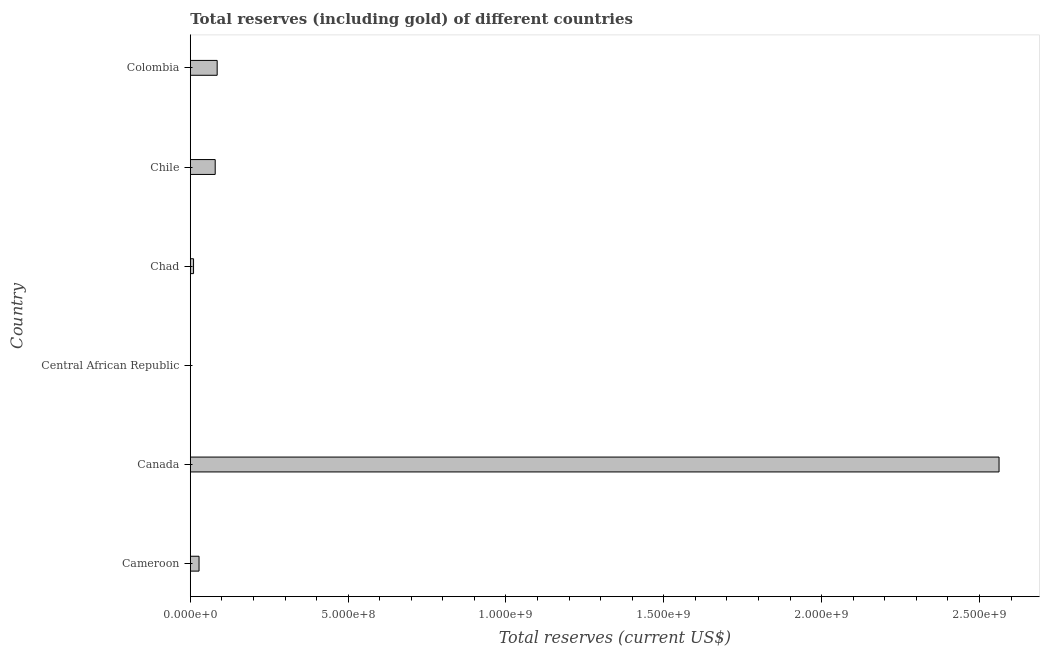Does the graph contain any zero values?
Your response must be concise. No. What is the title of the graph?
Your answer should be very brief. Total reserves (including gold) of different countries. What is the label or title of the X-axis?
Your answer should be very brief. Total reserves (current US$). What is the total reserves (including gold) in Colombia?
Your response must be concise. 8.51e+07. Across all countries, what is the maximum total reserves (including gold)?
Ensure brevity in your answer.  2.56e+09. In which country was the total reserves (including gold) minimum?
Your answer should be very brief. Central African Republic. What is the sum of the total reserves (including gold)?
Your answer should be very brief. 2.76e+09. What is the difference between the total reserves (including gold) in Canada and Chad?
Your answer should be compact. 2.55e+09. What is the average total reserves (including gold) per country?
Provide a succinct answer. 4.61e+08. What is the median total reserves (including gold)?
Offer a terse response. 5.33e+07. What is the ratio of the total reserves (including gold) in Cameroon to that in Colombia?
Your answer should be compact. 0.33. Is the total reserves (including gold) in Canada less than that in Chile?
Ensure brevity in your answer.  No. What is the difference between the highest and the second highest total reserves (including gold)?
Your answer should be compact. 2.48e+09. What is the difference between the highest and the lowest total reserves (including gold)?
Give a very brief answer. 2.56e+09. In how many countries, is the total reserves (including gold) greater than the average total reserves (including gold) taken over all countries?
Offer a terse response. 1. How many bars are there?
Keep it short and to the point. 6. Are all the bars in the graph horizontal?
Provide a short and direct response. Yes. What is the difference between two consecutive major ticks on the X-axis?
Keep it short and to the point. 5.00e+08. What is the Total reserves (current US$) of Cameroon?
Your answer should be compact. 2.77e+07. What is the Total reserves (current US$) in Canada?
Provide a succinct answer. 2.56e+09. What is the Total reserves (current US$) in Central African Republic?
Your response must be concise. 6.00e+05. What is the Total reserves (current US$) in Chad?
Provide a short and direct response. 1.03e+07. What is the Total reserves (current US$) in Chile?
Ensure brevity in your answer.  7.89e+07. What is the Total reserves (current US$) of Colombia?
Provide a succinct answer. 8.51e+07. What is the difference between the Total reserves (current US$) in Cameroon and Canada?
Provide a succinct answer. -2.53e+09. What is the difference between the Total reserves (current US$) in Cameroon and Central African Republic?
Your answer should be compact. 2.71e+07. What is the difference between the Total reserves (current US$) in Cameroon and Chad?
Make the answer very short. 1.74e+07. What is the difference between the Total reserves (current US$) in Cameroon and Chile?
Provide a succinct answer. -5.12e+07. What is the difference between the Total reserves (current US$) in Cameroon and Colombia?
Your response must be concise. -5.74e+07. What is the difference between the Total reserves (current US$) in Canada and Central African Republic?
Your answer should be very brief. 2.56e+09. What is the difference between the Total reserves (current US$) in Canada and Chad?
Offer a very short reply. 2.55e+09. What is the difference between the Total reserves (current US$) in Canada and Chile?
Offer a very short reply. 2.48e+09. What is the difference between the Total reserves (current US$) in Canada and Colombia?
Offer a terse response. 2.48e+09. What is the difference between the Total reserves (current US$) in Central African Republic and Chad?
Your response must be concise. -9.70e+06. What is the difference between the Total reserves (current US$) in Central African Republic and Chile?
Your response must be concise. -7.83e+07. What is the difference between the Total reserves (current US$) in Central African Republic and Colombia?
Offer a terse response. -8.45e+07. What is the difference between the Total reserves (current US$) in Chad and Chile?
Offer a terse response. -6.86e+07. What is the difference between the Total reserves (current US$) in Chad and Colombia?
Offer a terse response. -7.48e+07. What is the difference between the Total reserves (current US$) in Chile and Colombia?
Give a very brief answer. -6.24e+06. What is the ratio of the Total reserves (current US$) in Cameroon to that in Canada?
Keep it short and to the point. 0.01. What is the ratio of the Total reserves (current US$) in Cameroon to that in Central African Republic?
Provide a short and direct response. 46.18. What is the ratio of the Total reserves (current US$) in Cameroon to that in Chad?
Your answer should be compact. 2.69. What is the ratio of the Total reserves (current US$) in Cameroon to that in Chile?
Offer a very short reply. 0.35. What is the ratio of the Total reserves (current US$) in Cameroon to that in Colombia?
Offer a very short reply. 0.33. What is the ratio of the Total reserves (current US$) in Canada to that in Central African Republic?
Offer a very short reply. 4269.87. What is the ratio of the Total reserves (current US$) in Canada to that in Chad?
Provide a succinct answer. 248.73. What is the ratio of the Total reserves (current US$) in Canada to that in Chile?
Make the answer very short. 32.47. What is the ratio of the Total reserves (current US$) in Canada to that in Colombia?
Your answer should be very brief. 30.09. What is the ratio of the Total reserves (current US$) in Central African Republic to that in Chad?
Your response must be concise. 0.06. What is the ratio of the Total reserves (current US$) in Central African Republic to that in Chile?
Provide a succinct answer. 0.01. What is the ratio of the Total reserves (current US$) in Central African Republic to that in Colombia?
Your answer should be compact. 0.01. What is the ratio of the Total reserves (current US$) in Chad to that in Chile?
Your response must be concise. 0.13. What is the ratio of the Total reserves (current US$) in Chad to that in Colombia?
Ensure brevity in your answer.  0.12. What is the ratio of the Total reserves (current US$) in Chile to that in Colombia?
Make the answer very short. 0.93. 